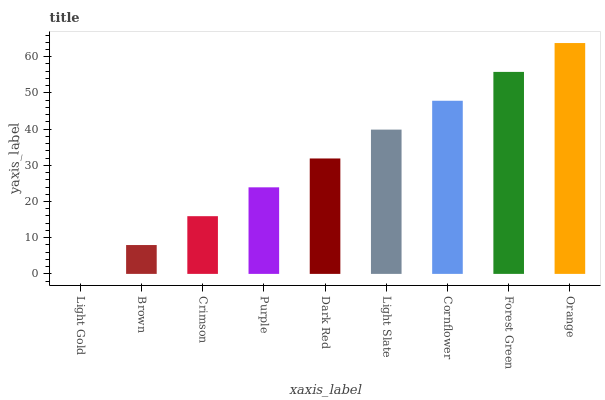Is Light Gold the minimum?
Answer yes or no. Yes. Is Orange the maximum?
Answer yes or no. Yes. Is Brown the minimum?
Answer yes or no. No. Is Brown the maximum?
Answer yes or no. No. Is Brown greater than Light Gold?
Answer yes or no. Yes. Is Light Gold less than Brown?
Answer yes or no. Yes. Is Light Gold greater than Brown?
Answer yes or no. No. Is Brown less than Light Gold?
Answer yes or no. No. Is Dark Red the high median?
Answer yes or no. Yes. Is Dark Red the low median?
Answer yes or no. Yes. Is Purple the high median?
Answer yes or no. No. Is Light Slate the low median?
Answer yes or no. No. 